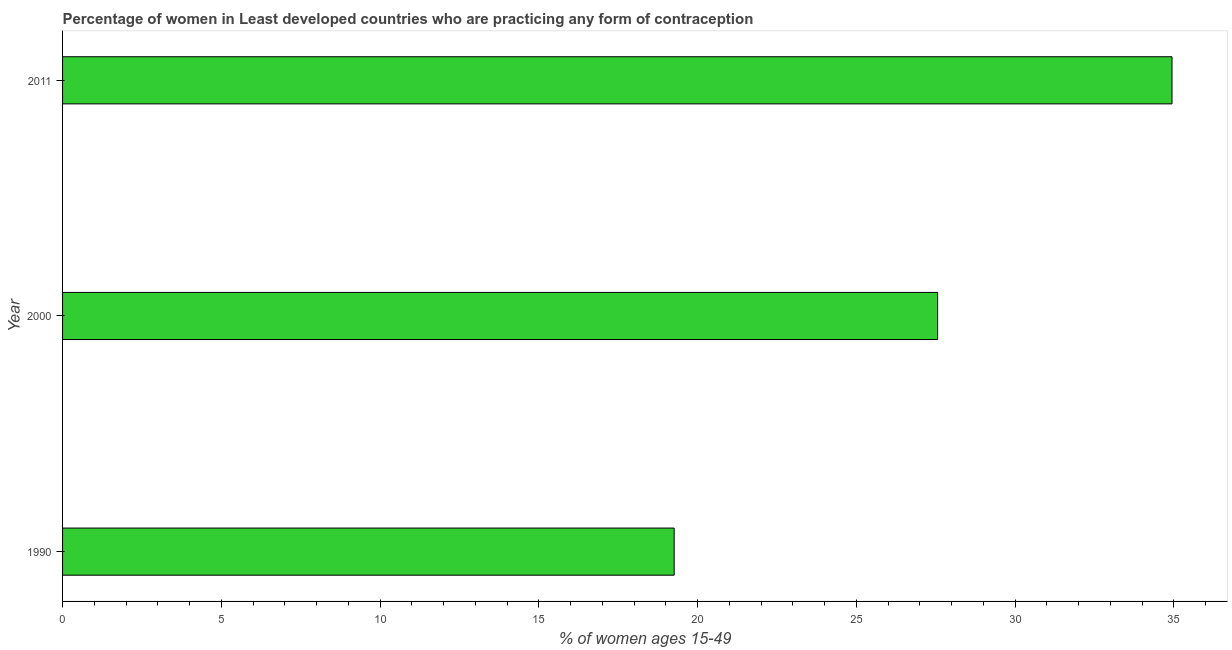What is the title of the graph?
Give a very brief answer. Percentage of women in Least developed countries who are practicing any form of contraception. What is the label or title of the X-axis?
Your response must be concise. % of women ages 15-49. What is the label or title of the Y-axis?
Make the answer very short. Year. What is the contraceptive prevalence in 1990?
Offer a terse response. 19.26. Across all years, what is the maximum contraceptive prevalence?
Provide a short and direct response. 34.94. Across all years, what is the minimum contraceptive prevalence?
Offer a very short reply. 19.26. In which year was the contraceptive prevalence maximum?
Provide a succinct answer. 2011. In which year was the contraceptive prevalence minimum?
Offer a terse response. 1990. What is the sum of the contraceptive prevalence?
Keep it short and to the point. 81.77. What is the difference between the contraceptive prevalence in 2000 and 2011?
Offer a very short reply. -7.38. What is the average contraceptive prevalence per year?
Provide a succinct answer. 27.26. What is the median contraceptive prevalence?
Offer a very short reply. 27.56. Do a majority of the years between 1990 and 2000 (inclusive) have contraceptive prevalence greater than 30 %?
Provide a short and direct response. No. What is the ratio of the contraceptive prevalence in 2000 to that in 2011?
Your answer should be compact. 0.79. Is the contraceptive prevalence in 1990 less than that in 2000?
Give a very brief answer. Yes. Is the difference between the contraceptive prevalence in 1990 and 2011 greater than the difference between any two years?
Your answer should be very brief. Yes. What is the difference between the highest and the second highest contraceptive prevalence?
Make the answer very short. 7.38. What is the difference between the highest and the lowest contraceptive prevalence?
Give a very brief answer. 15.68. In how many years, is the contraceptive prevalence greater than the average contraceptive prevalence taken over all years?
Make the answer very short. 2. Are the values on the major ticks of X-axis written in scientific E-notation?
Offer a terse response. No. What is the % of women ages 15-49 in 1990?
Keep it short and to the point. 19.26. What is the % of women ages 15-49 in 2000?
Provide a succinct answer. 27.56. What is the % of women ages 15-49 of 2011?
Provide a short and direct response. 34.94. What is the difference between the % of women ages 15-49 in 1990 and 2000?
Give a very brief answer. -8.3. What is the difference between the % of women ages 15-49 in 1990 and 2011?
Provide a short and direct response. -15.68. What is the difference between the % of women ages 15-49 in 2000 and 2011?
Your response must be concise. -7.38. What is the ratio of the % of women ages 15-49 in 1990 to that in 2000?
Offer a very short reply. 0.7. What is the ratio of the % of women ages 15-49 in 1990 to that in 2011?
Your answer should be compact. 0.55. What is the ratio of the % of women ages 15-49 in 2000 to that in 2011?
Your answer should be compact. 0.79. 